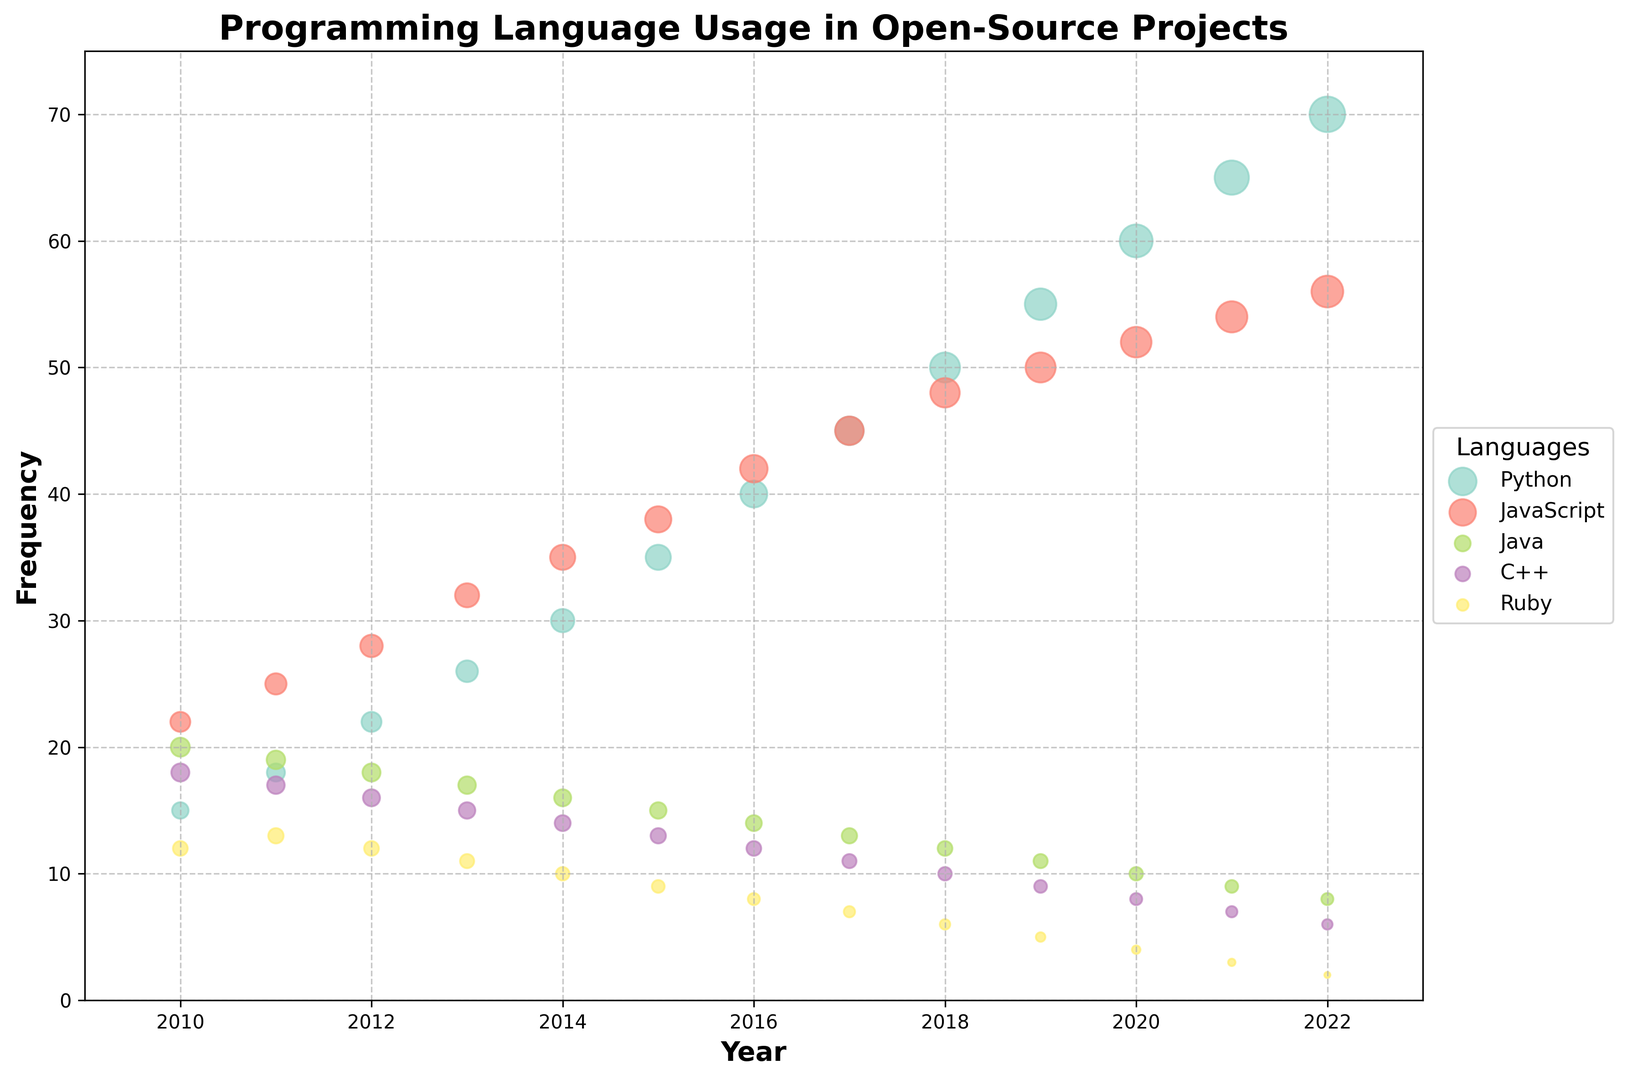Which programming language saw the most significant increase in usage from 2010 to 2022? To find the answer, look for the programming language with the largest difference in frequencies between 2010 and 2022. Python's frequency increased from 15 in 2010 to 70 in 2022, a difference of 55. This is the largest increase compared to other languages.
Answer: Python Which programming language had about the same usage frequency in 2017? In 2017, two programming languages had similar frequencies. By looking at the data points for that year, Python and JavaScript both had a frequency of 45.
Answer: Python and JavaScript What’s the average frequency of Ruby from 2010 to 2022? The frequencies for Ruby from 2010 to 2022 are 12, 13, 12, 11, 10, 9, 8, 7, 6, 5, 4, 3, 2. Summing these gives 102, and there are 13 years, so the average is 102/13 ≈ 7.85.
Answer: 7.85 Which year did C++ start declining in usage frequency? Look for the year when C++ usage frequency started decreasing continuously. The frequency was 18 in 2010 and began decreasing after 2011. The consistent decline starts from 2011 onwards.
Answer: 2011 How does the frequency of JavaScript in 2015 compare to the frequency of Python in the same year? Comparing the frequencies for JavaScript and Python in 2015, JavaScript had a frequency of 38, and Python had 35.
Answer: JavaScript had a higher frequency In which year did Java's frequency fall below 10? To find the year when Java's usage frequency first fell below 10, look at its data points. Java had a frequency of 9 in 2021, which is the first time it was below 10.
Answer: 2021 Calculate the difference in frequency between the highest and lowest values of JavaScript usage frequency over the years. The highest frequency of JavaScript over the years is 56 in 2022, and the lowest is 22 in 2010. The difference is 56 - 22 = 34.
Answer: 34 Identify the language with the smallest bubble size in 2022 and provide its frequency. The smallest bubble size in 2022 indicates the language with the lowest frequency. Ruby has the smallest bubble size with a frequency of 2.
Answer: Ruby, 2 Which languages showed an increasing trend from 2010 to 2022? To determine which languages showed an increasing trend, examine the progression of frequencies over the years. Both Python and JavaScript show an increasing trend from 2010 to 2022.
Answer: Python and JavaScript What is the sum of the frequencies of Python and JavaScript in 2020? The frequencies of Python and JavaScript in 2020 are 60 and 52, respectively. The sum is 60 + 52 = 112.
Answer: 112 